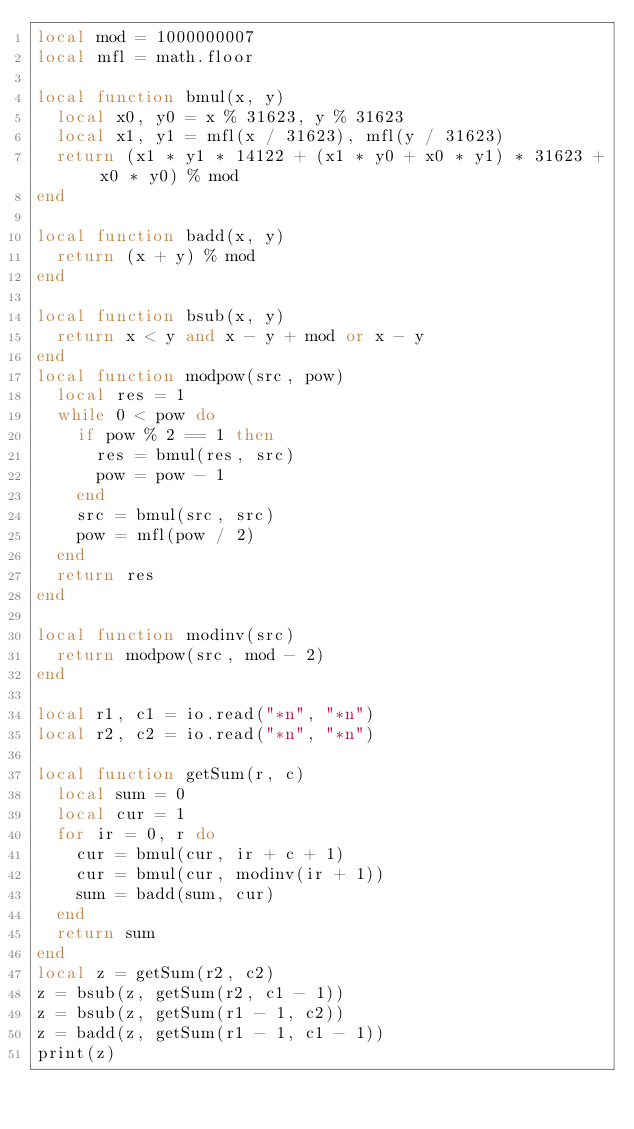<code> <loc_0><loc_0><loc_500><loc_500><_Lua_>local mod = 1000000007
local mfl = math.floor

local function bmul(x, y)
  local x0, y0 = x % 31623, y % 31623
  local x1, y1 = mfl(x / 31623), mfl(y / 31623)
  return (x1 * y1 * 14122 + (x1 * y0 + x0 * y1) * 31623 + x0 * y0) % mod
end

local function badd(x, y)
  return (x + y) % mod
end

local function bsub(x, y)
  return x < y and x - y + mod or x - y
end
local function modpow(src, pow)
  local res = 1
  while 0 < pow do
    if pow % 2 == 1 then
      res = bmul(res, src)
      pow = pow - 1
    end
    src = bmul(src, src)
    pow = mfl(pow / 2)
  end
  return res
end

local function modinv(src)
  return modpow(src, mod - 2)
end

local r1, c1 = io.read("*n", "*n")
local r2, c2 = io.read("*n", "*n")

local function getSum(r, c)
  local sum = 0
  local cur = 1
  for ir = 0, r do
    cur = bmul(cur, ir + c + 1)
    cur = bmul(cur, modinv(ir + 1))
    sum = badd(sum, cur)
  end
  return sum
end
local z = getSum(r2, c2)
z = bsub(z, getSum(r2, c1 - 1))
z = bsub(z, getSum(r1 - 1, c2))
z = badd(z, getSum(r1 - 1, c1 - 1))
print(z)
</code> 